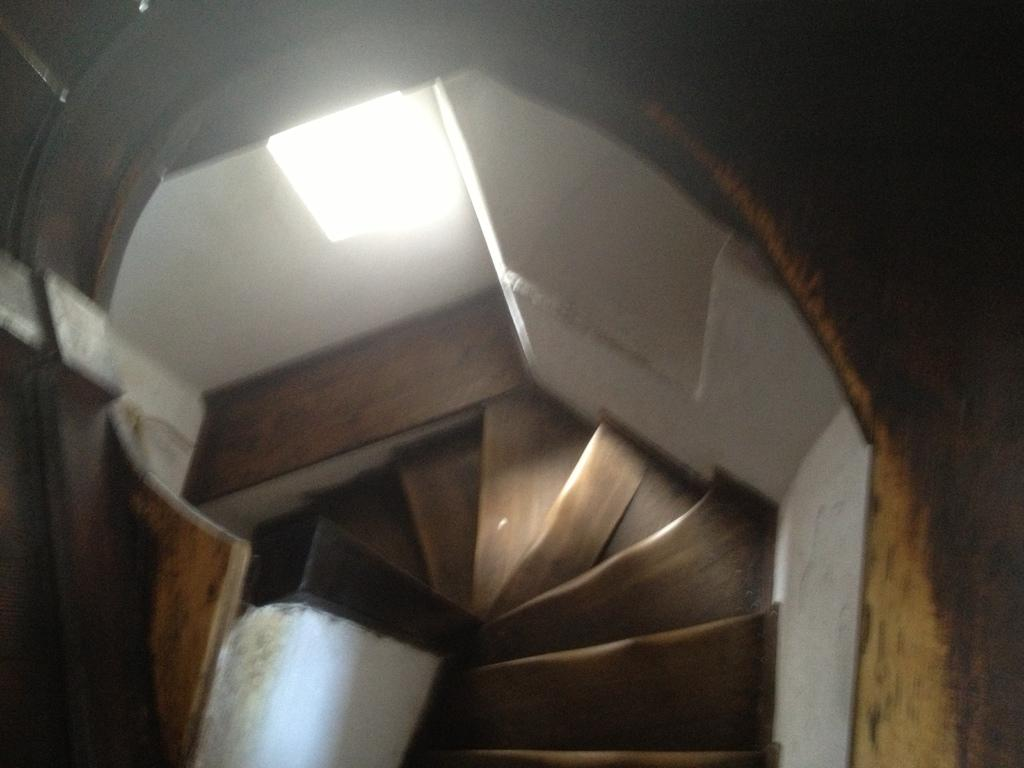What is located in the foreground of the image? There is a wall, stairs, and a light in the foreground of the image. Can you describe the wall in the image? The wall is in the foreground of the image. What is the purpose of the stairs in the image? The stairs are in the foreground of the image, but their purpose is not explicitly stated. What type of lighting is present in the image? There is a light in the foreground of the image. Can you see any fairies dancing around the light in the image? There are no fairies present in the image; it only features a wall, stairs, and a light. What type of street is visible in the image? There is no street visible in the image; it only features a wall, stairs, and a light. 